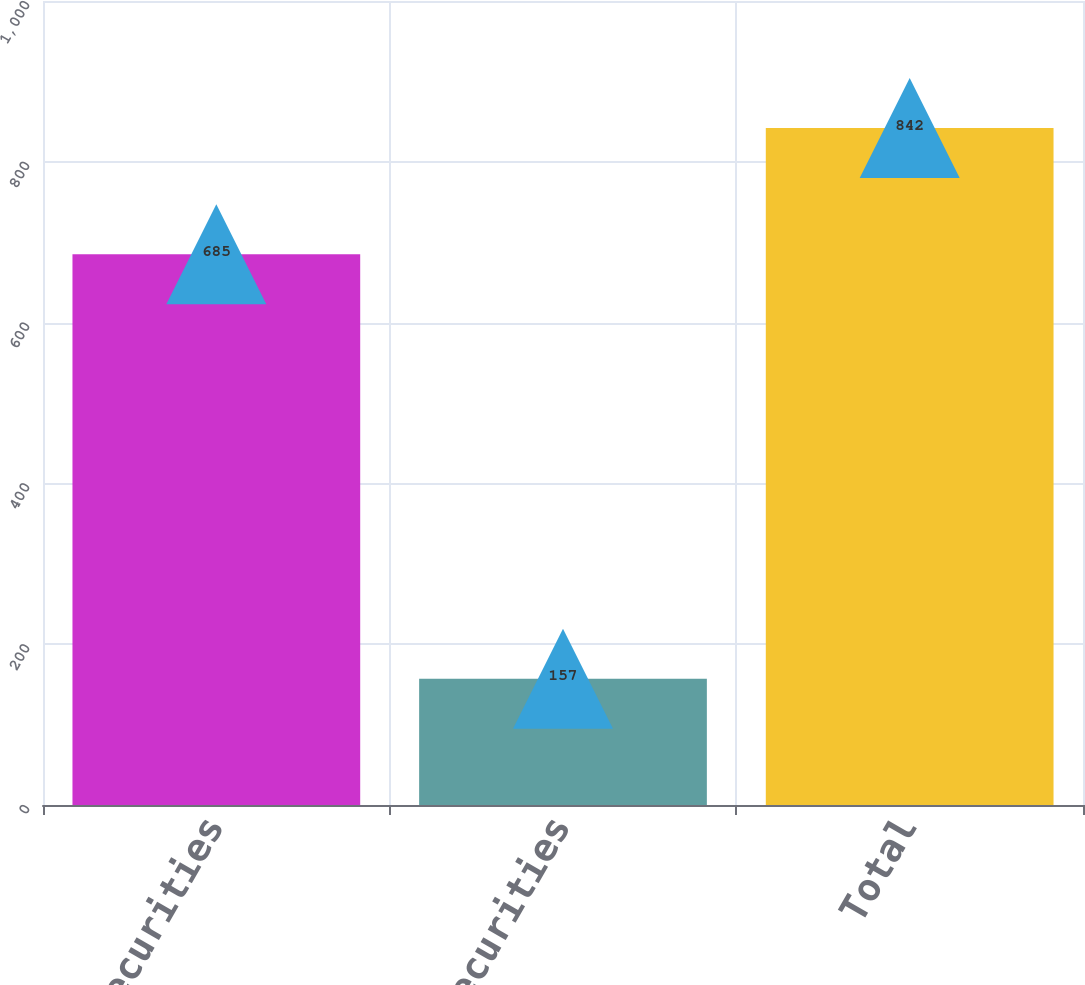Convert chart to OTSL. <chart><loc_0><loc_0><loc_500><loc_500><bar_chart><fcel>Equity securities<fcel>Debt securities<fcel>Total<nl><fcel>685<fcel>157<fcel>842<nl></chart> 